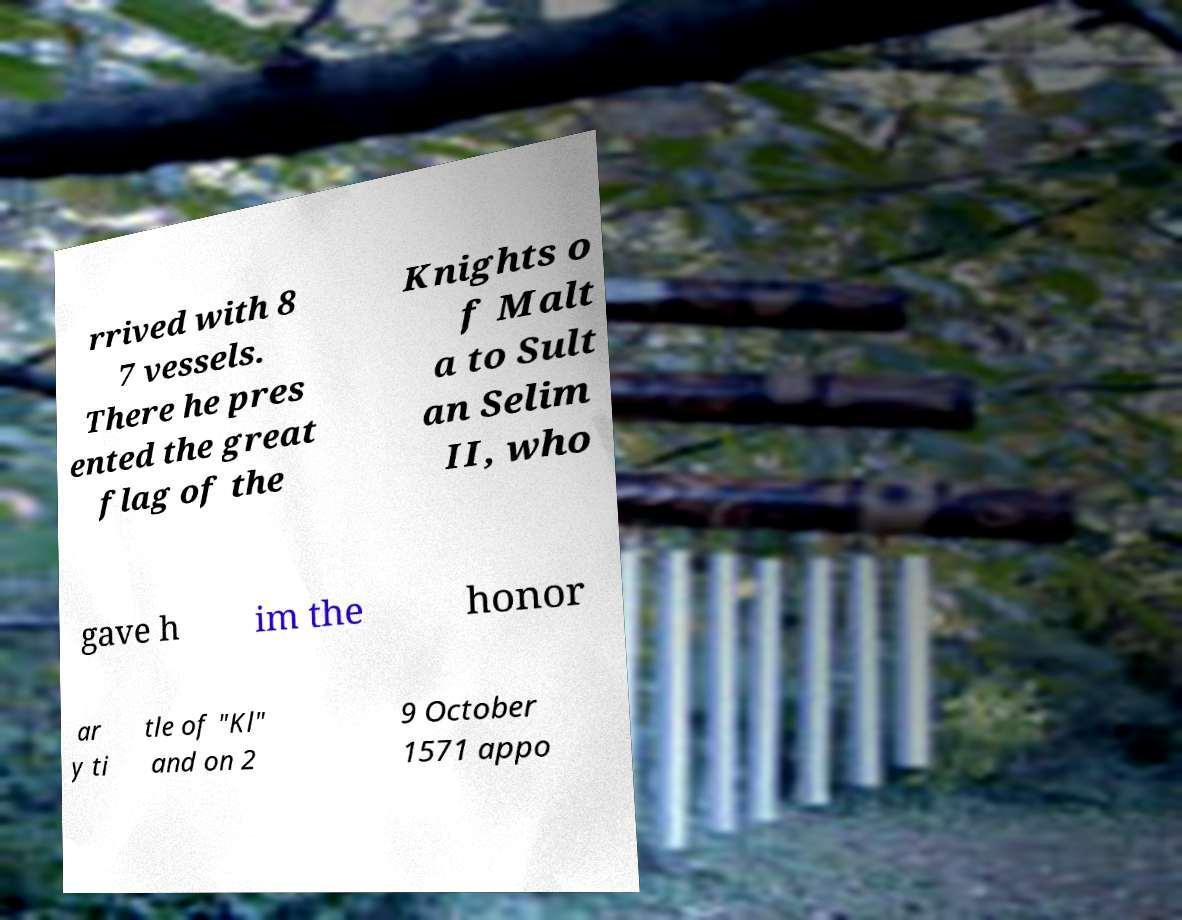Please identify and transcribe the text found in this image. rrived with 8 7 vessels. There he pres ented the great flag of the Knights o f Malt a to Sult an Selim II, who gave h im the honor ar y ti tle of "Kl" and on 2 9 October 1571 appo 